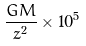Convert formula to latex. <formula><loc_0><loc_0><loc_500><loc_500>\frac { G M } { z ^ { 2 } } \times 1 0 ^ { 5 }</formula> 